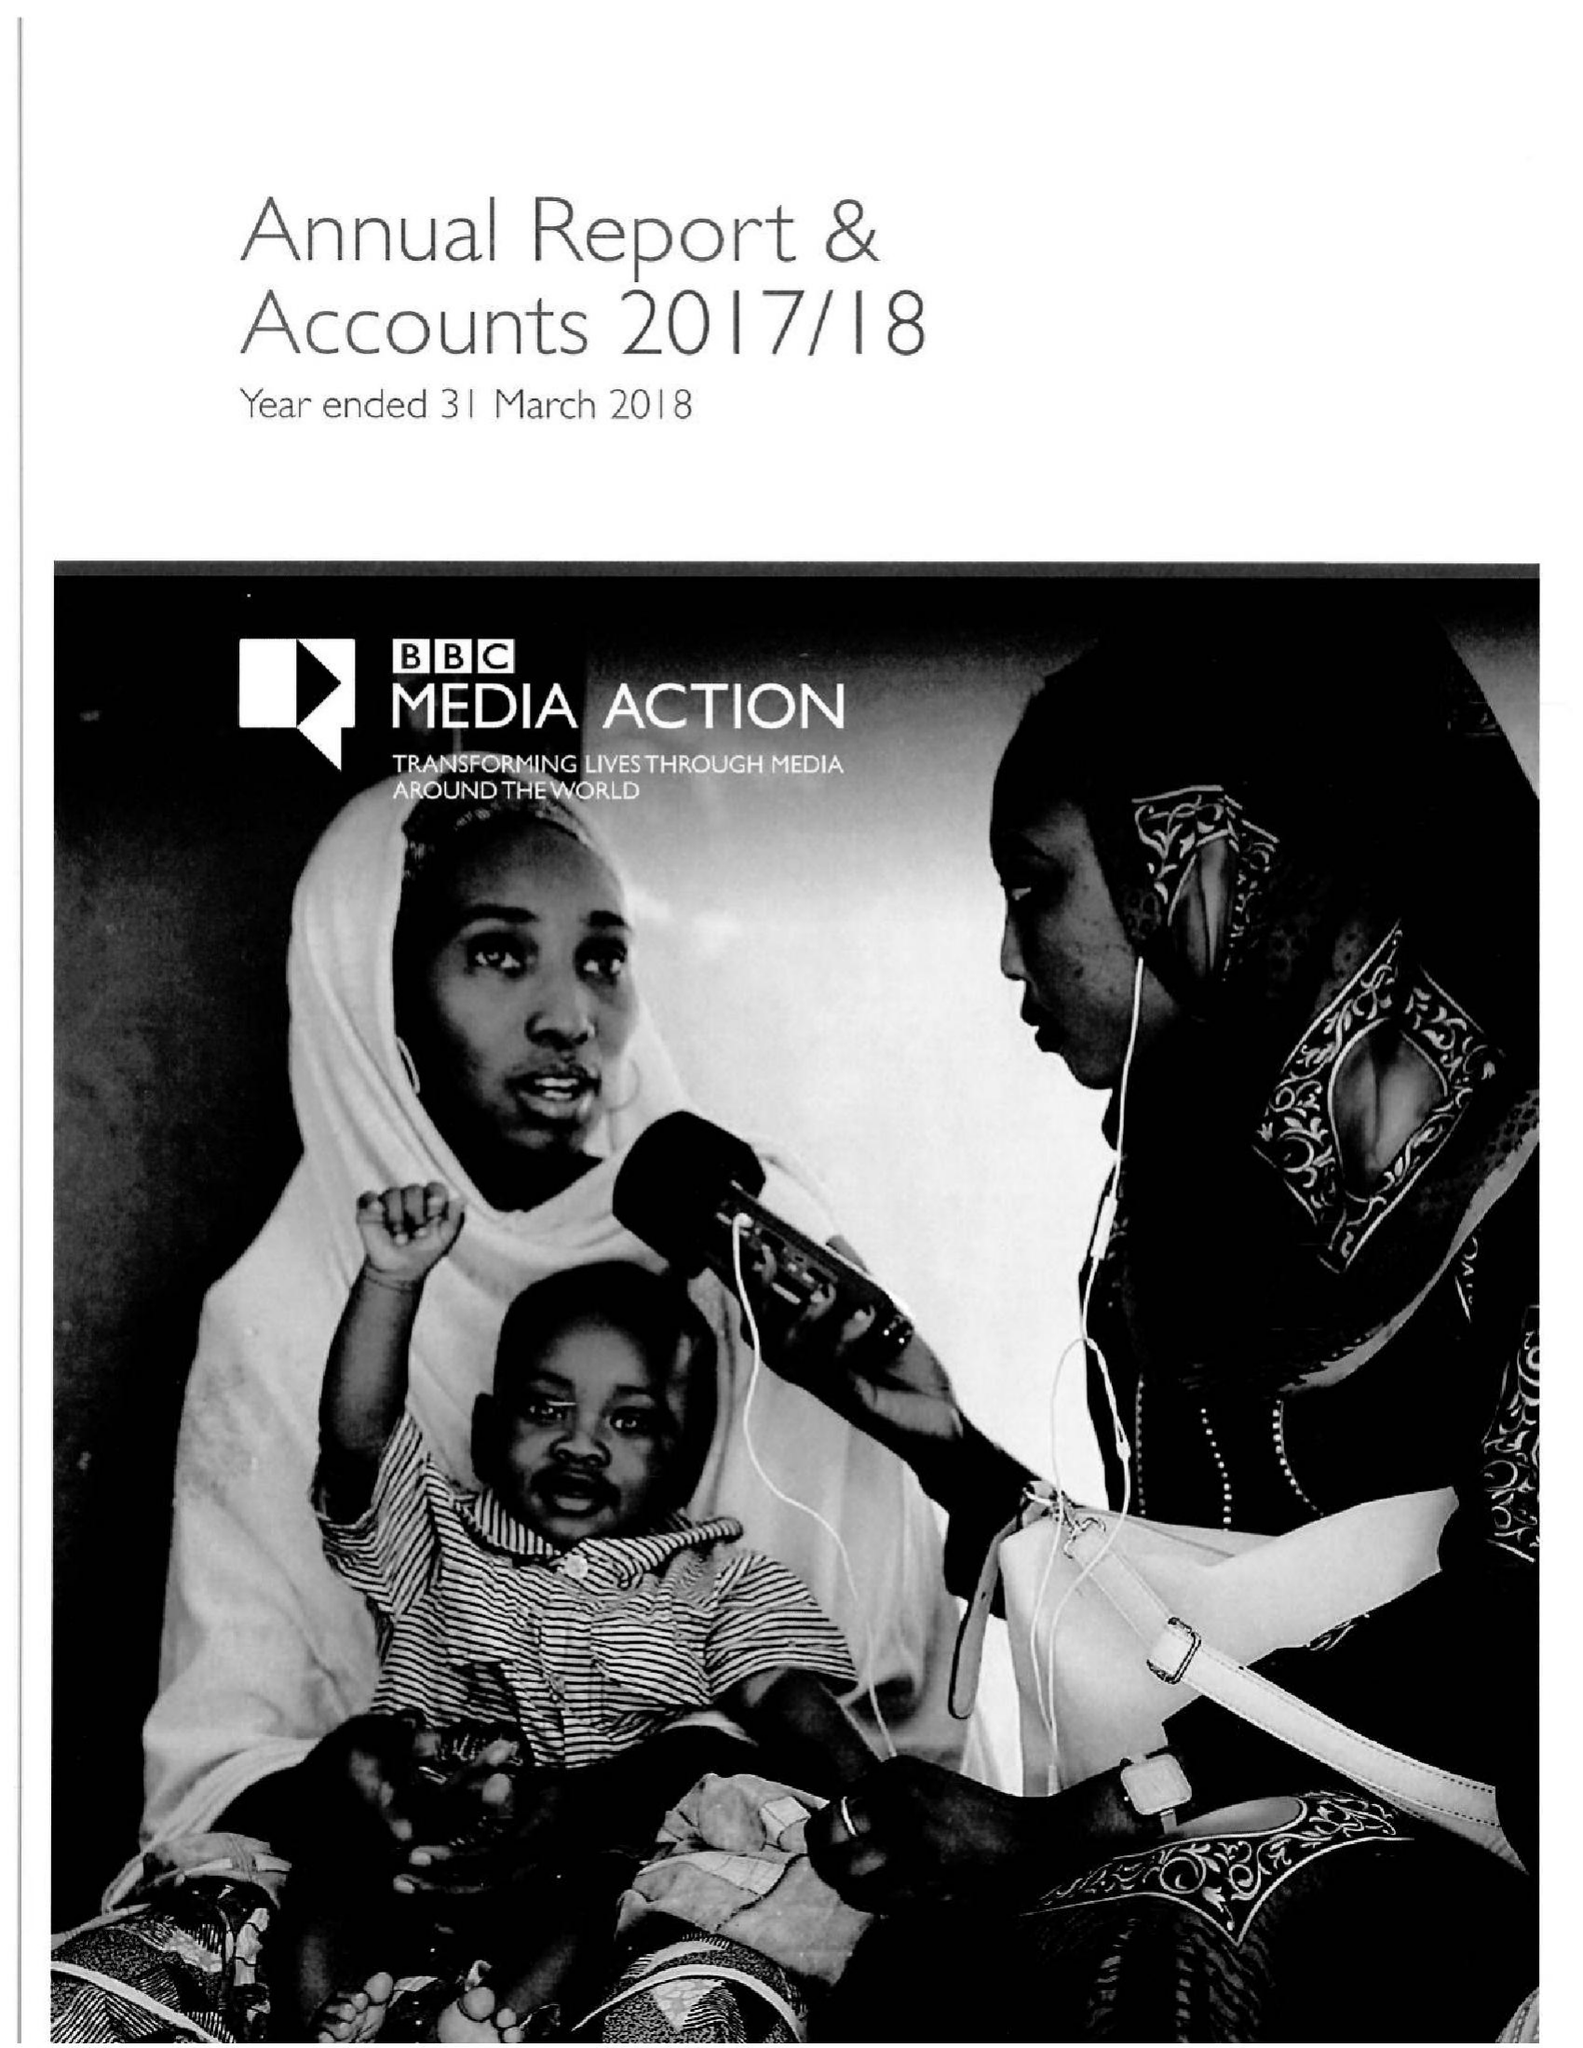What is the value for the address__postcode?
Answer the question using a single word or phrase. W1A 1AA 